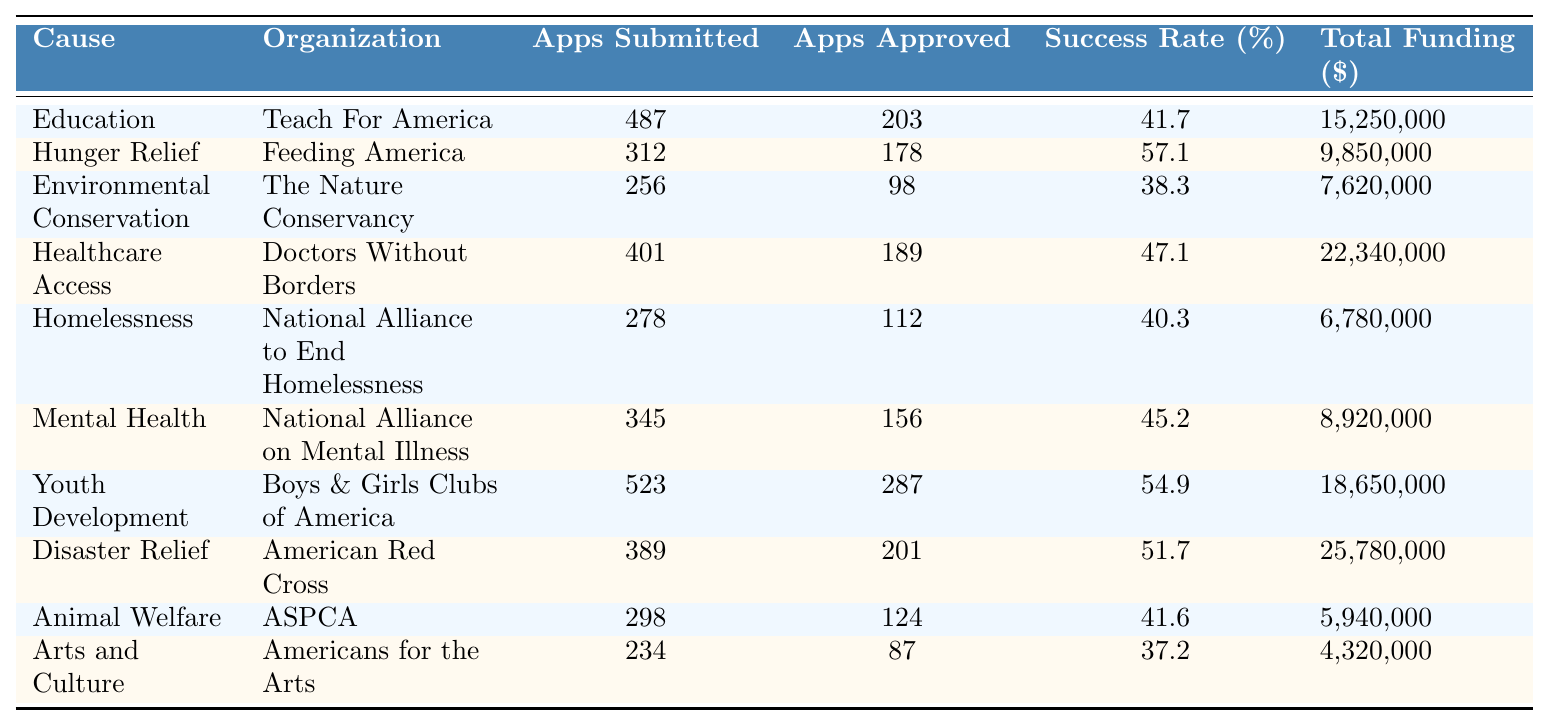What is the total funding secured for Hunger Relief initiatives? The table shows that Feeding America, which focuses on Hunger Relief, secured a total of 9,850,000 in funding.
Answer: 9,850,000 Which organization had the highest success rate among the listed causes? By comparing the success rates in the table, Feeding America has the highest success rate at 57.1%.
Answer: Feeding America What is the average success rate across all the causes listed? The success rates can be added together: (41.7 + 57.1 + 38.3 + 47.1 + 40.3 + 45.2 + 54.9 + 51.7 + 41.6 + 37.2) = 414.1. Dividing by the number of causes (10): 414.1 / 10 = 41.41.
Answer: 41.41 Is the success rate of Animal Welfare higher than that of Environmental Conservation? The success rate for Animal Welfare is 41.6%, while Environmental Conservation has a rate of 38.3%. Since 41.6% is greater than 38.3%, the statement is true.
Answer: Yes How much more total funding was secured for Disaster Relief compared to Arts and Culture? The total funding for Disaster Relief is 25,780,000 and for Arts and Culture is 4,320,000. The difference is 25,780,000 - 4,320,000 = 21,460,000.
Answer: 21,460,000 What percentage of applications submitted by the organization focused on Mental Health were approved? The number of applications approved for Mental Health is 156, and the total applications submitted is 345. To find the percentage: (156 / 345) * 100 = 45.2%.
Answer: 45.2% If you combine the total funding secured from Education and Mental Health, what is the total? The total funding secured for Education is 15,250,000 and for Mental Health is 8,920,000. Adding them gives 15,250,000 + 8,920,000 = 24,170,000.
Answer: 24,170,000 Which cause had the lowest success rate and what was that rate? By examining the success rates in the table, Environmental Conservation has the lowest success rate at 38.3%.
Answer: Environmental Conservation, 38.3% Are there more applications submitted for Youth Development than for Healthcare Access? Youth Development had 523 applications submitted, while Healthcare Access had 401. Since 523 is greater than 401, the statement is true.
Answer: Yes What is the ratio of applications approved for Healthcare Access compared to those submitted for Homelessness? Applications approved for Healthcare Access is 189, and for Homelessness, it is 112. The ratio of 189 to 112 can be simplified to approximately 1.69 to 1.
Answer: 1.69 to 1 